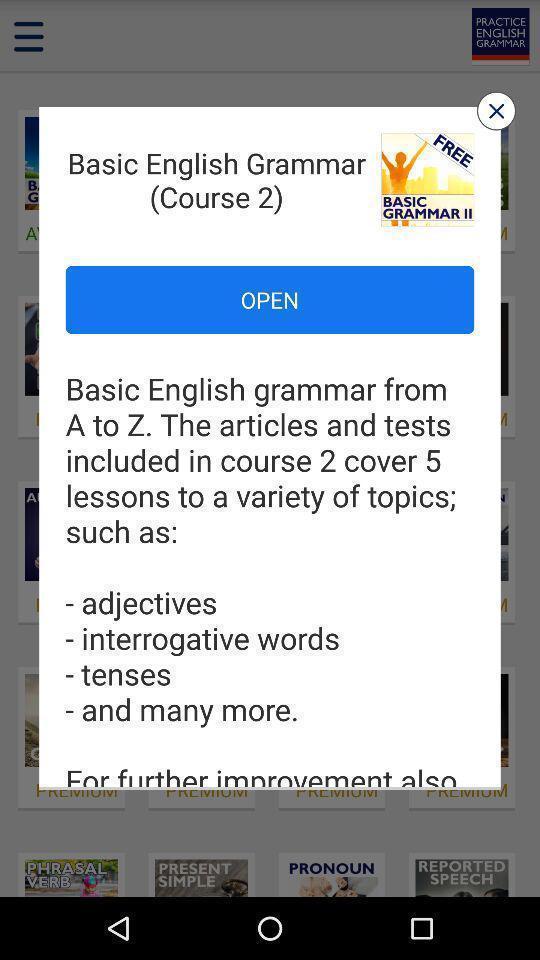Describe the key features of this screenshot. Pop up showing language grammar application. 